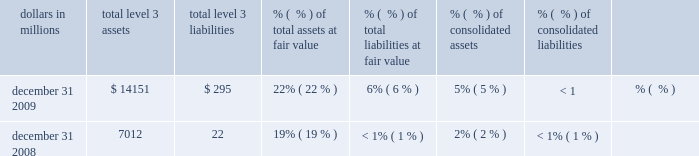Pricing the loans .
When available , valuation assumptions included observable inputs based on whole loan sales .
Adjustments are made to these assumptions to account for situations when uncertainties exist , including market conditions and liquidity .
Credit risk is included as part of our valuation process for these loans by considering expected rates of return for market participants for similar loans in the marketplace .
Based on the significance of unobservable inputs , we classify this portfolio as level 3 .
Equity investments the valuation of direct and indirect private equity investments requires significant management judgment due to the absence of quoted market prices , inherent lack of liquidity and the long-term nature of such investments .
The carrying values of direct and affiliated partnership interests reflect the expected exit price and are based on various techniques including publicly traded price , multiples of adjusted earnings of the entity , independent appraisals , anticipated financing and sale transactions with third parties , or the pricing used to value the entity in a recent financing transaction .
In september 2009 , the fasb issued asu 2009-12 2013 fair value measurements and disclosures ( topic 820 ) 2013 investments in certain entities that calculate net asset value per share ( or its equivalent ) .
Based on the guidance , we value indirect investments in private equity funds based on net asset value as provided in the financial statements that we receive from their managers .
Due to the time lag in our receipt of the financial information and based on a review of investments and valuation techniques applied , adjustments to the manager-provided value are made when available recent portfolio company information or market information indicates a significant change in value from that provided by the manager of the fund .
These investments are classified as level 3 .
Customer resale agreements we account for structured resale agreements , which are economically hedged using free-standing financial derivatives , at fair value .
The fair value for structured resale agreements is determined using a model which includes observable market data such as interest rates as inputs .
Readily observable market inputs to this model can be validated to external sources , including yield curves , implied volatility or other market-related data .
These instruments are classified as level 2 .
Blackrock series c preferred stock effective february 27 , 2009 , we elected to account for the approximately 2.9 million shares of the blackrock series c preferred stock received in a stock exchange with blackrock at fair value .
The series c preferred stock economically hedges the blackrock ltip liability that is accounted for as a derivative .
The fair value of the series c preferred stock is determined using a third-party modeling approach , which includes both observable and unobservable inputs .
This approach considers expectations of a default/liquidation event and the use of liquidity discounts based on our inability to sell the security at a fair , open market price in a timely manner .
Due to the significance of unobservable inputs , this security is classified as level 3 .
Level 3 assets and liabilities financial instruments are considered level 3 when their values are determined using pricing models , discounted cash flow methodologies or similar techniques and at least one significant model assumption or input is unobservable .
Level 3 assets and liabilities dollars in millions level 3 assets level 3 liabilities % (  % ) of total assets at fair value % (  % ) of total liabilities at fair value consolidated assets consolidated liabilities .
During 2009 , securities transferred into level 3 from level 2 exceeded securities transferred out by $ 4.4 billion .
Total securities measured at fair value and classified in level 3 at december 31 , 2009 and december 31 , 2008 included securities available for sale and trading securities consisting primarily of non-agency residential mortgage-backed securities and asset- backed securities where management determined that the volume and level of activity for these assets had significantly decreased .
There have been no recent new 201cprivate label 201d issues in the residential mortgage-backed securities market .
The lack of relevant market activity for these securities resulted in management modifying its valuation methodology for the instruments transferred in 2009 .
Other level 3 assets include certain commercial mortgage loans held for sale , certain equity securities , auction rate securities , corporate debt securities , private equity investments , residential mortgage servicing rights and other assets. .
What percentage increase was there between 2008 and 2009 re : level 3 assets? 
Computations: (((14151 - 7012) / 7012) * 100)
Answer: 101.81118. Pricing the loans .
When available , valuation assumptions included observable inputs based on whole loan sales .
Adjustments are made to these assumptions to account for situations when uncertainties exist , including market conditions and liquidity .
Credit risk is included as part of our valuation process for these loans by considering expected rates of return for market participants for similar loans in the marketplace .
Based on the significance of unobservable inputs , we classify this portfolio as level 3 .
Equity investments the valuation of direct and indirect private equity investments requires significant management judgment due to the absence of quoted market prices , inherent lack of liquidity and the long-term nature of such investments .
The carrying values of direct and affiliated partnership interests reflect the expected exit price and are based on various techniques including publicly traded price , multiples of adjusted earnings of the entity , independent appraisals , anticipated financing and sale transactions with third parties , or the pricing used to value the entity in a recent financing transaction .
In september 2009 , the fasb issued asu 2009-12 2013 fair value measurements and disclosures ( topic 820 ) 2013 investments in certain entities that calculate net asset value per share ( or its equivalent ) .
Based on the guidance , we value indirect investments in private equity funds based on net asset value as provided in the financial statements that we receive from their managers .
Due to the time lag in our receipt of the financial information and based on a review of investments and valuation techniques applied , adjustments to the manager-provided value are made when available recent portfolio company information or market information indicates a significant change in value from that provided by the manager of the fund .
These investments are classified as level 3 .
Customer resale agreements we account for structured resale agreements , which are economically hedged using free-standing financial derivatives , at fair value .
The fair value for structured resale agreements is determined using a model which includes observable market data such as interest rates as inputs .
Readily observable market inputs to this model can be validated to external sources , including yield curves , implied volatility or other market-related data .
These instruments are classified as level 2 .
Blackrock series c preferred stock effective february 27 , 2009 , we elected to account for the approximately 2.9 million shares of the blackrock series c preferred stock received in a stock exchange with blackrock at fair value .
The series c preferred stock economically hedges the blackrock ltip liability that is accounted for as a derivative .
The fair value of the series c preferred stock is determined using a third-party modeling approach , which includes both observable and unobservable inputs .
This approach considers expectations of a default/liquidation event and the use of liquidity discounts based on our inability to sell the security at a fair , open market price in a timely manner .
Due to the significance of unobservable inputs , this security is classified as level 3 .
Level 3 assets and liabilities financial instruments are considered level 3 when their values are determined using pricing models , discounted cash flow methodologies or similar techniques and at least one significant model assumption or input is unobservable .
Level 3 assets and liabilities dollars in millions level 3 assets level 3 liabilities % (  % ) of total assets at fair value % (  % ) of total liabilities at fair value consolidated assets consolidated liabilities .
During 2009 , securities transferred into level 3 from level 2 exceeded securities transferred out by $ 4.4 billion .
Total securities measured at fair value and classified in level 3 at december 31 , 2009 and december 31 , 2008 included securities available for sale and trading securities consisting primarily of non-agency residential mortgage-backed securities and asset- backed securities where management determined that the volume and level of activity for these assets had significantly decreased .
There have been no recent new 201cprivate label 201d issues in the residential mortgage-backed securities market .
The lack of relevant market activity for these securities resulted in management modifying its valuation methodology for the instruments transferred in 2009 .
Other level 3 assets include certain commercial mortgage loans held for sale , certain equity securities , auction rate securities , corporate debt securities , private equity investments , residential mortgage servicing rights and other assets. .
What was the increase in level 3 liabilities between december 31 2009 and december 31 2008 , in millions? 
Computations: (295 - 22)
Answer: 273.0. Pricing the loans .
When available , valuation assumptions included observable inputs based on whole loan sales .
Adjustments are made to these assumptions to account for situations when uncertainties exist , including market conditions and liquidity .
Credit risk is included as part of our valuation process for these loans by considering expected rates of return for market participants for similar loans in the marketplace .
Based on the significance of unobservable inputs , we classify this portfolio as level 3 .
Equity investments the valuation of direct and indirect private equity investments requires significant management judgment due to the absence of quoted market prices , inherent lack of liquidity and the long-term nature of such investments .
The carrying values of direct and affiliated partnership interests reflect the expected exit price and are based on various techniques including publicly traded price , multiples of adjusted earnings of the entity , independent appraisals , anticipated financing and sale transactions with third parties , or the pricing used to value the entity in a recent financing transaction .
In september 2009 , the fasb issued asu 2009-12 2013 fair value measurements and disclosures ( topic 820 ) 2013 investments in certain entities that calculate net asset value per share ( or its equivalent ) .
Based on the guidance , we value indirect investments in private equity funds based on net asset value as provided in the financial statements that we receive from their managers .
Due to the time lag in our receipt of the financial information and based on a review of investments and valuation techniques applied , adjustments to the manager-provided value are made when available recent portfolio company information or market information indicates a significant change in value from that provided by the manager of the fund .
These investments are classified as level 3 .
Customer resale agreements we account for structured resale agreements , which are economically hedged using free-standing financial derivatives , at fair value .
The fair value for structured resale agreements is determined using a model which includes observable market data such as interest rates as inputs .
Readily observable market inputs to this model can be validated to external sources , including yield curves , implied volatility or other market-related data .
These instruments are classified as level 2 .
Blackrock series c preferred stock effective february 27 , 2009 , we elected to account for the approximately 2.9 million shares of the blackrock series c preferred stock received in a stock exchange with blackrock at fair value .
The series c preferred stock economically hedges the blackrock ltip liability that is accounted for as a derivative .
The fair value of the series c preferred stock is determined using a third-party modeling approach , which includes both observable and unobservable inputs .
This approach considers expectations of a default/liquidation event and the use of liquidity discounts based on our inability to sell the security at a fair , open market price in a timely manner .
Due to the significance of unobservable inputs , this security is classified as level 3 .
Level 3 assets and liabilities financial instruments are considered level 3 when their values are determined using pricing models , discounted cash flow methodologies or similar techniques and at least one significant model assumption or input is unobservable .
Level 3 assets and liabilities dollars in millions level 3 assets level 3 liabilities % (  % ) of total assets at fair value % (  % ) of total liabilities at fair value consolidated assets consolidated liabilities .
During 2009 , securities transferred into level 3 from level 2 exceeded securities transferred out by $ 4.4 billion .
Total securities measured at fair value and classified in level 3 at december 31 , 2009 and december 31 , 2008 included securities available for sale and trading securities consisting primarily of non-agency residential mortgage-backed securities and asset- backed securities where management determined that the volume and level of activity for these assets had significantly decreased .
There have been no recent new 201cprivate label 201d issues in the residential mortgage-backed securities market .
The lack of relevant market activity for these securities resulted in management modifying its valuation methodology for the instruments transferred in 2009 .
Other level 3 assets include certain commercial mortgage loans held for sale , certain equity securities , auction rate securities , corporate debt securities , private equity investments , residential mortgage servicing rights and other assets. .
How much more , in millions , are the total level 3 assets than the level 3 liabilities for year ended dec 31 , 2009? 
Computations: (14151 - 295)
Answer: 13856.0. 